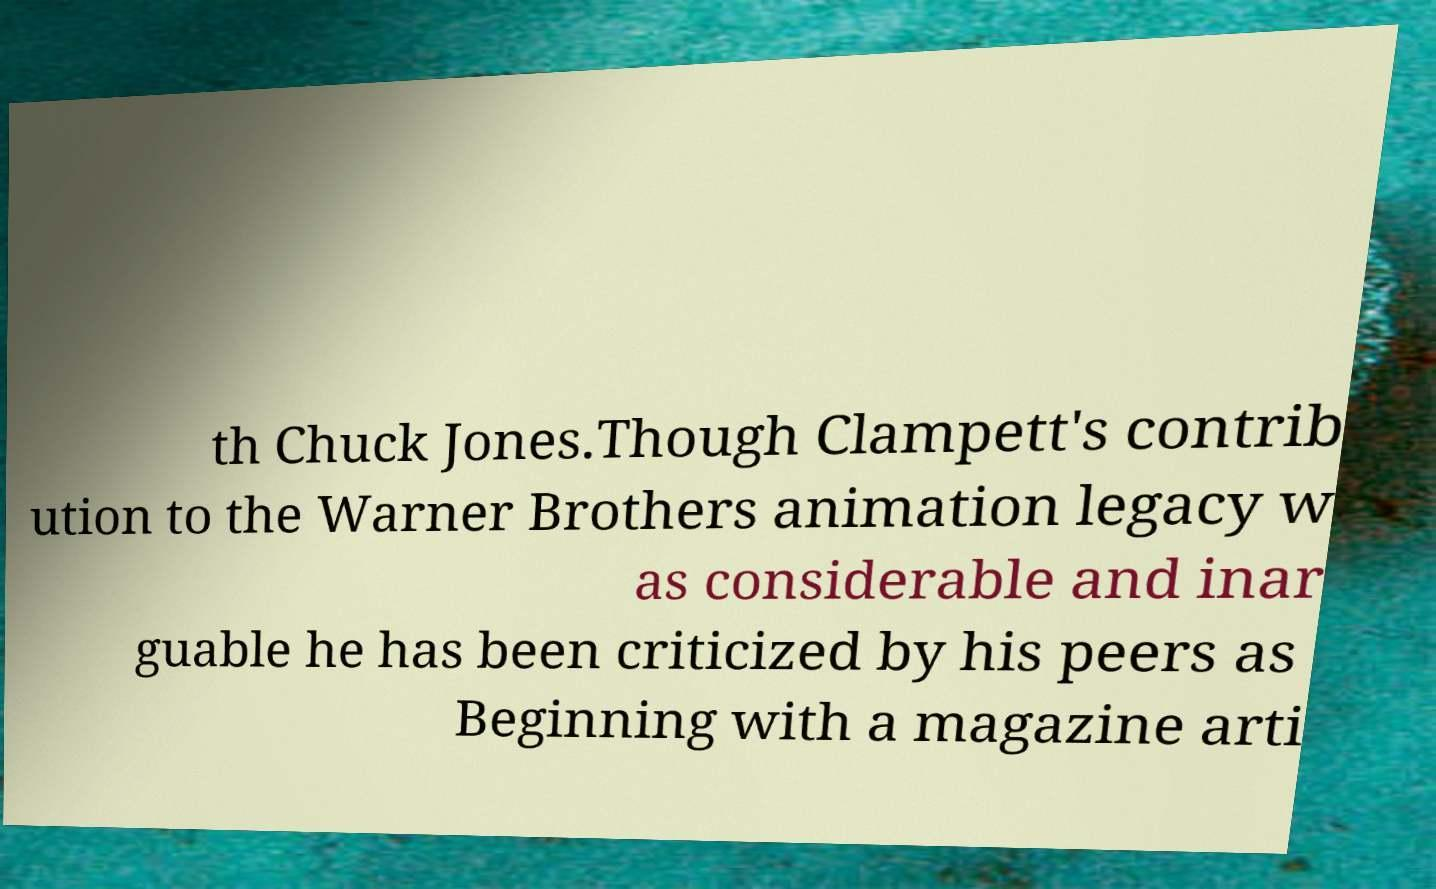Could you assist in decoding the text presented in this image and type it out clearly? th Chuck Jones.Though Clampett's contrib ution to the Warner Brothers animation legacy w as considerable and inar guable he has been criticized by his peers as Beginning with a magazine arti 